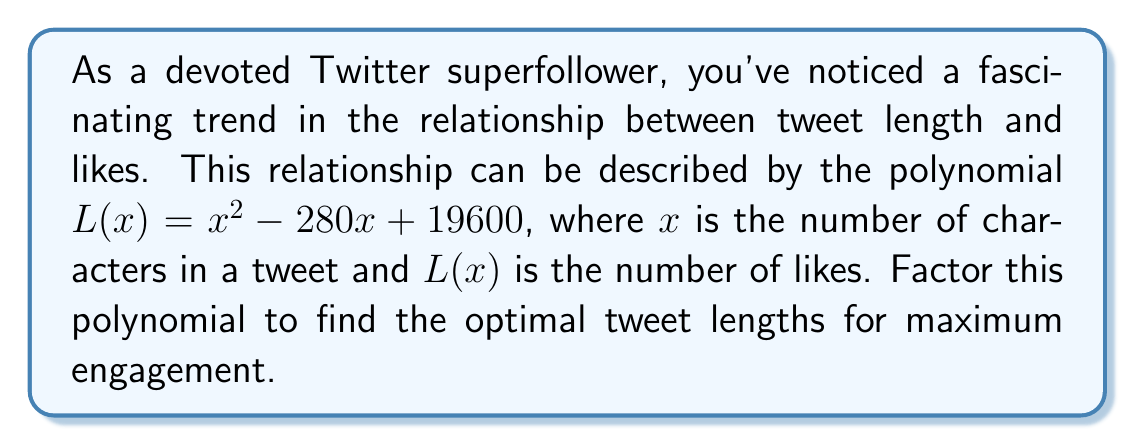What is the answer to this math problem? To factor this quadratic polynomial, we'll use the following steps:

1) First, identify the polynomial: $L(x) = x^2 - 280x + 19600$

2) This is in the form $ax^2 + bx + c$, where $a=1$, $b=-280$, and $c=19600$

3) We'll use the quadratic formula to find the roots:
   $x = \frac{-b \pm \sqrt{b^2 - 4ac}}{2a}$

4) Substituting our values:
   $x = \frac{280 \pm \sqrt{(-280)^2 - 4(1)(19600)}}{2(1)}$

5) Simplify under the square root:
   $x = \frac{280 \pm \sqrt{78400 - 78400}}{2}$

6) Simplify further:
   $x = \frac{280 \pm \sqrt{0}}{2} = \frac{280 \pm 0}{2} = 140$

7) Since both roots are the same, we can factor the polynomial as:
   $L(x) = (x - 140)(x - 140)$

8) This can be written as:
   $L(x) = (x - 140)^2$

This factorization reveals that the optimal tweet length for maximum likes is 140 characters, which coincidentally was the original character limit on Twitter before it was increased to 280.
Answer: $L(x) = (x - 140)^2$ 